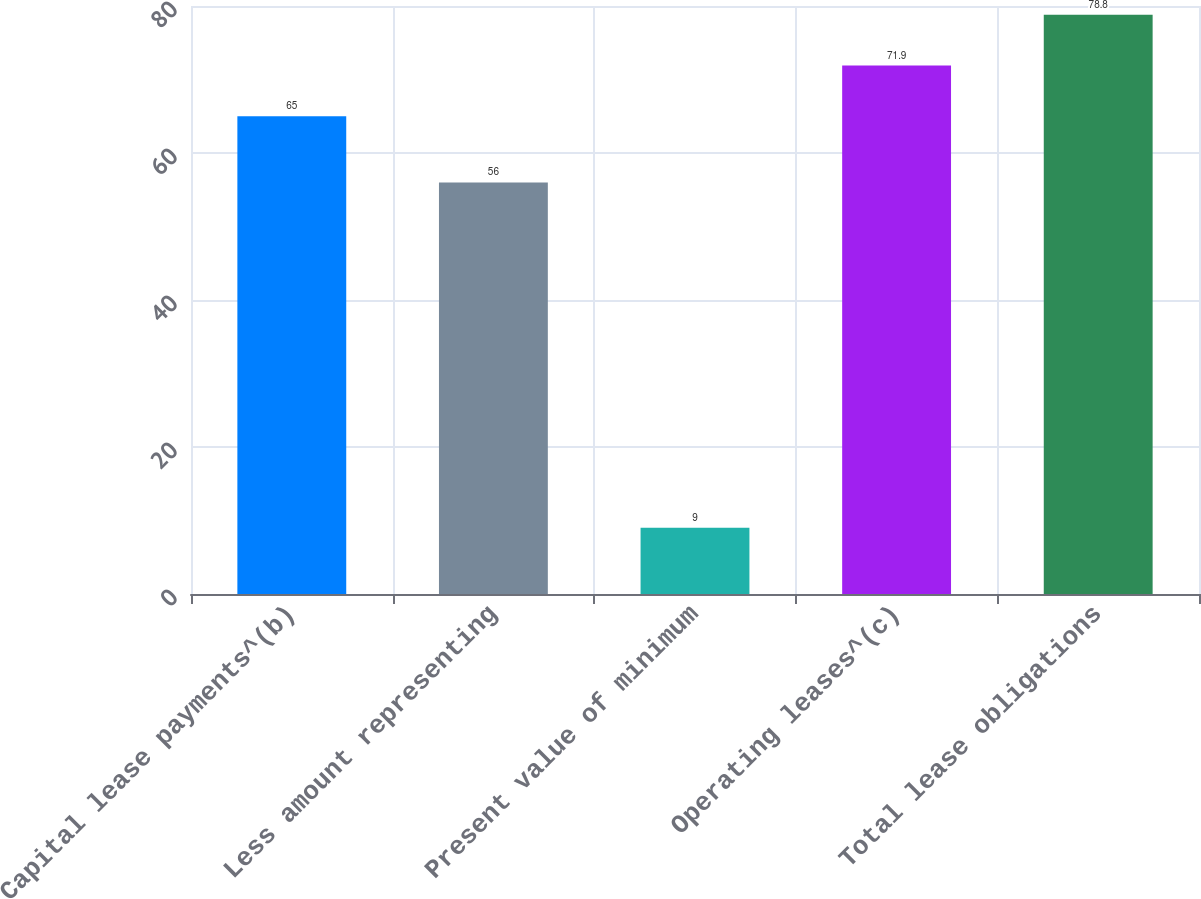Convert chart. <chart><loc_0><loc_0><loc_500><loc_500><bar_chart><fcel>Capital lease payments^(b)<fcel>Less amount representing<fcel>Present value of minimum<fcel>Operating leases^(c)<fcel>Total lease obligations<nl><fcel>65<fcel>56<fcel>9<fcel>71.9<fcel>78.8<nl></chart> 